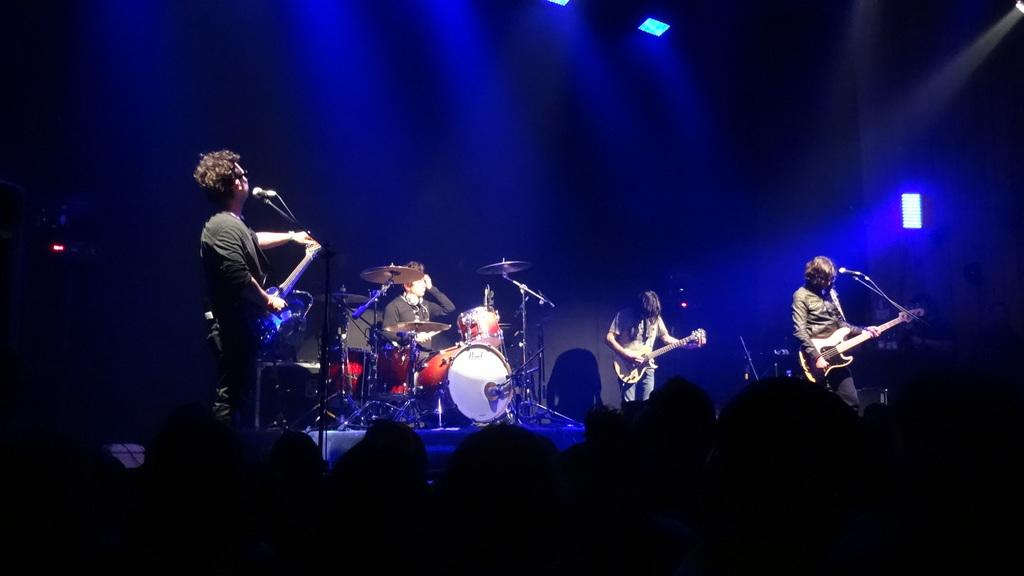What is happening in the image involving the group of people? The people in the image are playing musical instruments. What object is present that might be used for amplifying sound? There is a microphone in the image. Where does the scene take place? The scene takes place on a stage. What letter is being played on the piano in the image? There is no piano present in the image, and therefore no specific letter can be identified. What error is being corrected by the conductor in the image? There is no conductor or error present in the image. 